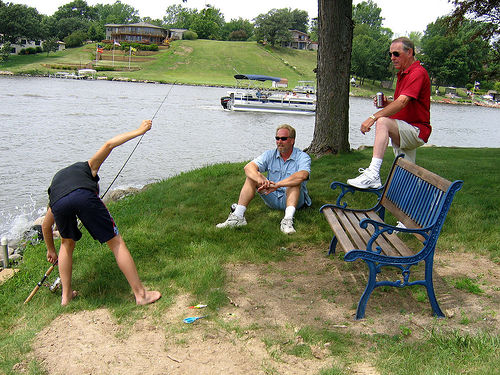<image>
Is the head in front of the water? Yes. The head is positioned in front of the water, appearing closer to the camera viewpoint. 